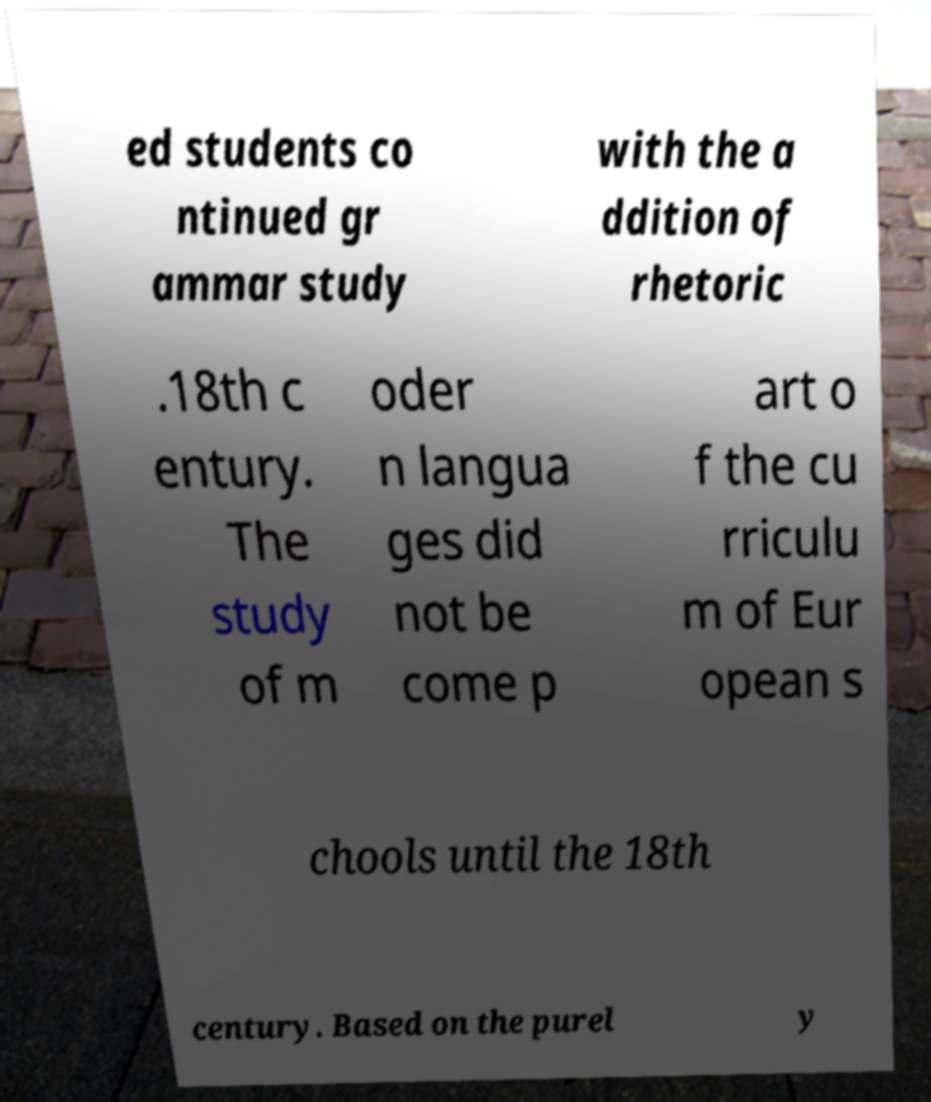Can you read and provide the text displayed in the image?This photo seems to have some interesting text. Can you extract and type it out for me? ed students co ntinued gr ammar study with the a ddition of rhetoric .18th c entury. The study of m oder n langua ges did not be come p art o f the cu rriculu m of Eur opean s chools until the 18th century. Based on the purel y 